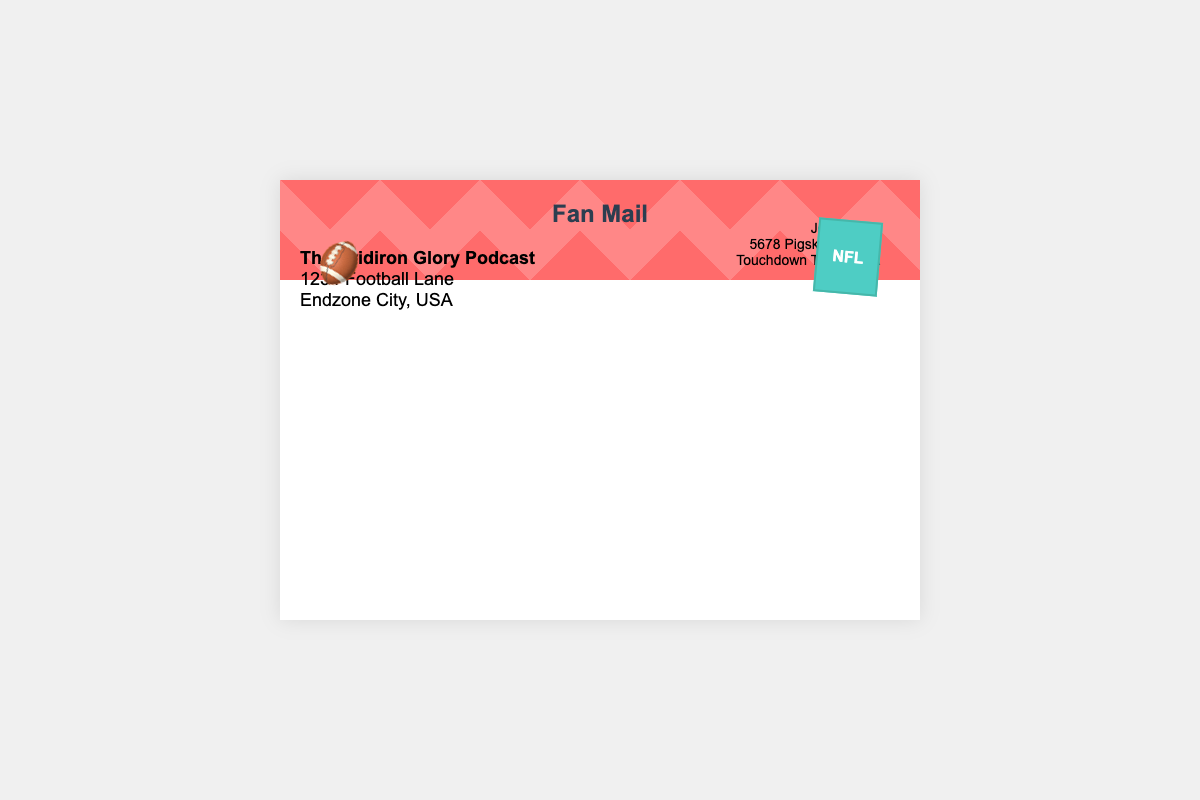What is the title of the envelope? The title is prominently displayed in the center of the envelope content.
Answer: Fan Mail Who is the sender of the mail? The sender's name and address are located in the top right section of the envelope.
Answer: John Davis What is the address of the podcast? The address is listed under the title and provides details on where the podcast is located.
Answer: 1234 Football Lane, Endzone City, USA What color is the stamp? The stamp has a specific background color that sets it apart visually.
Answer: Green Where is the stamp positioned on the envelope? The position of the stamp is indicated in the layout of the envelope.
Answer: Top right What decorative element is present at the bottom of the envelope? A decorative symbol adds to the theme of the envelope design.
Answer: Football emoji How many lines are in the address of the sender? The lines count the sender’s address to determine its structure.
Answer: Three lines 